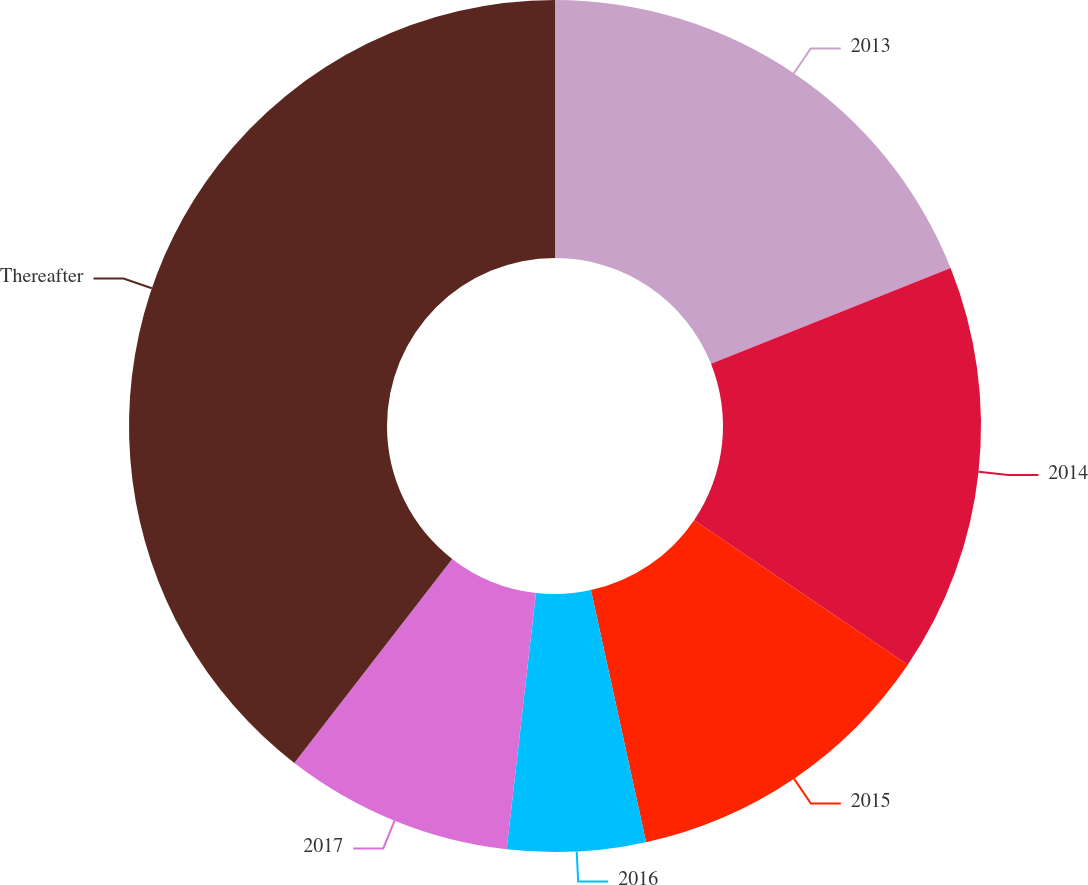Convert chart to OTSL. <chart><loc_0><loc_0><loc_500><loc_500><pie_chart><fcel>2013<fcel>2014<fcel>2015<fcel>2016<fcel>2017<fcel>Thereafter<nl><fcel>18.95%<fcel>15.52%<fcel>12.1%<fcel>5.24%<fcel>8.67%<fcel>39.52%<nl></chart> 